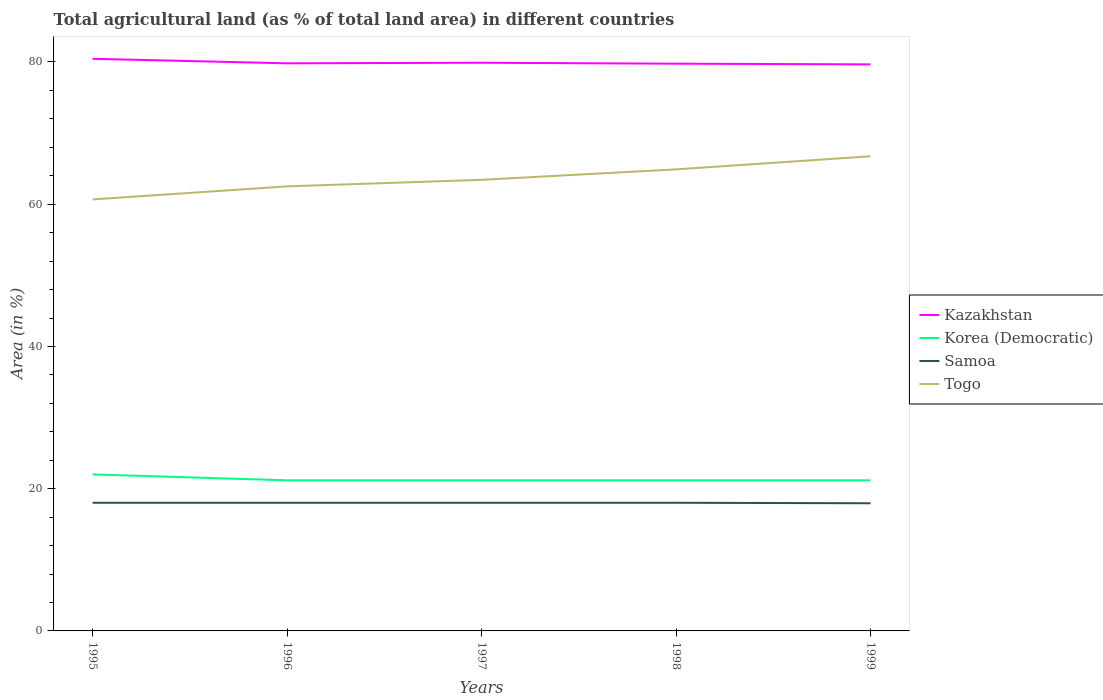Does the line corresponding to Korea (Democratic) intersect with the line corresponding to Togo?
Provide a short and direct response. No. Across all years, what is the maximum percentage of agricultural land in Samoa?
Your answer should be very brief. 17.95. In which year was the percentage of agricultural land in Samoa maximum?
Keep it short and to the point. 1999. What is the total percentage of agricultural land in Togo in the graph?
Keep it short and to the point. -3.31. What is the difference between the highest and the second highest percentage of agricultural land in Samoa?
Make the answer very short. 0.07. What is the difference between the highest and the lowest percentage of agricultural land in Korea (Democratic)?
Offer a very short reply. 1. How many years are there in the graph?
Provide a short and direct response. 5. What is the difference between two consecutive major ticks on the Y-axis?
Ensure brevity in your answer.  20. Does the graph contain any zero values?
Make the answer very short. No. Does the graph contain grids?
Ensure brevity in your answer.  No. Where does the legend appear in the graph?
Your response must be concise. Center right. How many legend labels are there?
Ensure brevity in your answer.  4. What is the title of the graph?
Offer a terse response. Total agricultural land (as % of total land area) in different countries. What is the label or title of the Y-axis?
Give a very brief answer. Area (in %). What is the Area (in %) in Kazakhstan in 1995?
Provide a succinct answer. 80.45. What is the Area (in %) in Korea (Democratic) in 1995?
Offer a very short reply. 22.01. What is the Area (in %) of Samoa in 1995?
Offer a very short reply. 18.02. What is the Area (in %) in Togo in 1995?
Make the answer very short. 60.67. What is the Area (in %) in Kazakhstan in 1996?
Your answer should be very brief. 79.81. What is the Area (in %) of Korea (Democratic) in 1996?
Offer a terse response. 21.18. What is the Area (in %) of Samoa in 1996?
Offer a terse response. 18.02. What is the Area (in %) of Togo in 1996?
Make the answer very short. 62.51. What is the Area (in %) of Kazakhstan in 1997?
Provide a short and direct response. 79.89. What is the Area (in %) in Korea (Democratic) in 1997?
Keep it short and to the point. 21.18. What is the Area (in %) of Samoa in 1997?
Offer a terse response. 18.02. What is the Area (in %) in Togo in 1997?
Provide a succinct answer. 63.43. What is the Area (in %) in Kazakhstan in 1998?
Ensure brevity in your answer.  79.76. What is the Area (in %) of Korea (Democratic) in 1998?
Keep it short and to the point. 21.18. What is the Area (in %) of Samoa in 1998?
Provide a succinct answer. 18.02. What is the Area (in %) of Togo in 1998?
Offer a very short reply. 64.9. What is the Area (in %) of Kazakhstan in 1999?
Ensure brevity in your answer.  79.67. What is the Area (in %) of Korea (Democratic) in 1999?
Offer a very short reply. 21.18. What is the Area (in %) in Samoa in 1999?
Give a very brief answer. 17.95. What is the Area (in %) in Togo in 1999?
Give a very brief answer. 66.74. Across all years, what is the maximum Area (in %) in Kazakhstan?
Keep it short and to the point. 80.45. Across all years, what is the maximum Area (in %) of Korea (Democratic)?
Your answer should be compact. 22.01. Across all years, what is the maximum Area (in %) in Samoa?
Give a very brief answer. 18.02. Across all years, what is the maximum Area (in %) in Togo?
Offer a terse response. 66.74. Across all years, what is the minimum Area (in %) of Kazakhstan?
Offer a very short reply. 79.67. Across all years, what is the minimum Area (in %) of Korea (Democratic)?
Provide a succinct answer. 21.18. Across all years, what is the minimum Area (in %) in Samoa?
Ensure brevity in your answer.  17.95. Across all years, what is the minimum Area (in %) in Togo?
Offer a terse response. 60.67. What is the total Area (in %) in Kazakhstan in the graph?
Provide a short and direct response. 399.58. What is the total Area (in %) in Korea (Democratic) in the graph?
Ensure brevity in your answer.  106.72. What is the total Area (in %) of Samoa in the graph?
Offer a terse response. 90.04. What is the total Area (in %) in Togo in the graph?
Your answer should be compact. 318.26. What is the difference between the Area (in %) in Kazakhstan in 1995 and that in 1996?
Your answer should be compact. 0.63. What is the difference between the Area (in %) in Korea (Democratic) in 1995 and that in 1996?
Offer a terse response. 0.83. What is the difference between the Area (in %) in Samoa in 1995 and that in 1996?
Keep it short and to the point. 0. What is the difference between the Area (in %) of Togo in 1995 and that in 1996?
Offer a very short reply. -1.84. What is the difference between the Area (in %) in Kazakhstan in 1995 and that in 1997?
Ensure brevity in your answer.  0.55. What is the difference between the Area (in %) in Korea (Democratic) in 1995 and that in 1997?
Give a very brief answer. 0.83. What is the difference between the Area (in %) of Samoa in 1995 and that in 1997?
Your response must be concise. 0. What is the difference between the Area (in %) in Togo in 1995 and that in 1997?
Make the answer very short. -2.76. What is the difference between the Area (in %) of Kazakhstan in 1995 and that in 1998?
Your response must be concise. 0.69. What is the difference between the Area (in %) in Korea (Democratic) in 1995 and that in 1998?
Your answer should be very brief. 0.83. What is the difference between the Area (in %) in Togo in 1995 and that in 1998?
Provide a short and direct response. -4.23. What is the difference between the Area (in %) of Kazakhstan in 1995 and that in 1999?
Offer a terse response. 0.78. What is the difference between the Area (in %) in Korea (Democratic) in 1995 and that in 1999?
Give a very brief answer. 0.83. What is the difference between the Area (in %) of Samoa in 1995 and that in 1999?
Your response must be concise. 0.07. What is the difference between the Area (in %) of Togo in 1995 and that in 1999?
Give a very brief answer. -6.07. What is the difference between the Area (in %) of Kazakhstan in 1996 and that in 1997?
Make the answer very short. -0.08. What is the difference between the Area (in %) of Korea (Democratic) in 1996 and that in 1997?
Offer a very short reply. 0. What is the difference between the Area (in %) of Samoa in 1996 and that in 1997?
Offer a terse response. 0. What is the difference between the Area (in %) in Togo in 1996 and that in 1997?
Provide a succinct answer. -0.92. What is the difference between the Area (in %) in Kazakhstan in 1996 and that in 1998?
Offer a very short reply. 0.05. What is the difference between the Area (in %) in Korea (Democratic) in 1996 and that in 1998?
Your answer should be compact. 0. What is the difference between the Area (in %) in Samoa in 1996 and that in 1998?
Your answer should be very brief. 0. What is the difference between the Area (in %) of Togo in 1996 and that in 1998?
Make the answer very short. -2.39. What is the difference between the Area (in %) in Kazakhstan in 1996 and that in 1999?
Keep it short and to the point. 0.15. What is the difference between the Area (in %) of Samoa in 1996 and that in 1999?
Provide a short and direct response. 0.07. What is the difference between the Area (in %) in Togo in 1996 and that in 1999?
Ensure brevity in your answer.  -4.23. What is the difference between the Area (in %) of Kazakhstan in 1997 and that in 1998?
Your answer should be compact. 0.13. What is the difference between the Area (in %) in Korea (Democratic) in 1997 and that in 1998?
Your answer should be very brief. 0. What is the difference between the Area (in %) in Togo in 1997 and that in 1998?
Provide a succinct answer. -1.47. What is the difference between the Area (in %) of Kazakhstan in 1997 and that in 1999?
Ensure brevity in your answer.  0.23. What is the difference between the Area (in %) of Samoa in 1997 and that in 1999?
Your answer should be very brief. 0.07. What is the difference between the Area (in %) in Togo in 1997 and that in 1999?
Provide a succinct answer. -3.31. What is the difference between the Area (in %) in Kazakhstan in 1998 and that in 1999?
Your response must be concise. 0.09. What is the difference between the Area (in %) in Samoa in 1998 and that in 1999?
Make the answer very short. 0.07. What is the difference between the Area (in %) in Togo in 1998 and that in 1999?
Your answer should be very brief. -1.84. What is the difference between the Area (in %) in Kazakhstan in 1995 and the Area (in %) in Korea (Democratic) in 1996?
Ensure brevity in your answer.  59.27. What is the difference between the Area (in %) of Kazakhstan in 1995 and the Area (in %) of Samoa in 1996?
Offer a terse response. 62.43. What is the difference between the Area (in %) in Kazakhstan in 1995 and the Area (in %) in Togo in 1996?
Provide a short and direct response. 17.94. What is the difference between the Area (in %) of Korea (Democratic) in 1995 and the Area (in %) of Samoa in 1996?
Your answer should be very brief. 3.99. What is the difference between the Area (in %) in Korea (Democratic) in 1995 and the Area (in %) in Togo in 1996?
Give a very brief answer. -40.5. What is the difference between the Area (in %) in Samoa in 1995 and the Area (in %) in Togo in 1996?
Keep it short and to the point. -44.49. What is the difference between the Area (in %) of Kazakhstan in 1995 and the Area (in %) of Korea (Democratic) in 1997?
Offer a terse response. 59.27. What is the difference between the Area (in %) in Kazakhstan in 1995 and the Area (in %) in Samoa in 1997?
Ensure brevity in your answer.  62.43. What is the difference between the Area (in %) in Kazakhstan in 1995 and the Area (in %) in Togo in 1997?
Give a very brief answer. 17.02. What is the difference between the Area (in %) of Korea (Democratic) in 1995 and the Area (in %) of Samoa in 1997?
Your response must be concise. 3.99. What is the difference between the Area (in %) in Korea (Democratic) in 1995 and the Area (in %) in Togo in 1997?
Keep it short and to the point. -41.42. What is the difference between the Area (in %) of Samoa in 1995 and the Area (in %) of Togo in 1997?
Ensure brevity in your answer.  -45.41. What is the difference between the Area (in %) of Kazakhstan in 1995 and the Area (in %) of Korea (Democratic) in 1998?
Ensure brevity in your answer.  59.27. What is the difference between the Area (in %) of Kazakhstan in 1995 and the Area (in %) of Samoa in 1998?
Offer a terse response. 62.43. What is the difference between the Area (in %) in Kazakhstan in 1995 and the Area (in %) in Togo in 1998?
Keep it short and to the point. 15.55. What is the difference between the Area (in %) of Korea (Democratic) in 1995 and the Area (in %) of Samoa in 1998?
Your answer should be very brief. 3.99. What is the difference between the Area (in %) in Korea (Democratic) in 1995 and the Area (in %) in Togo in 1998?
Keep it short and to the point. -42.89. What is the difference between the Area (in %) in Samoa in 1995 and the Area (in %) in Togo in 1998?
Your answer should be compact. -46.88. What is the difference between the Area (in %) of Kazakhstan in 1995 and the Area (in %) of Korea (Democratic) in 1999?
Keep it short and to the point. 59.27. What is the difference between the Area (in %) of Kazakhstan in 1995 and the Area (in %) of Samoa in 1999?
Offer a terse response. 62.5. What is the difference between the Area (in %) of Kazakhstan in 1995 and the Area (in %) of Togo in 1999?
Provide a short and direct response. 13.71. What is the difference between the Area (in %) in Korea (Democratic) in 1995 and the Area (in %) in Samoa in 1999?
Keep it short and to the point. 4.06. What is the difference between the Area (in %) of Korea (Democratic) in 1995 and the Area (in %) of Togo in 1999?
Make the answer very short. -44.73. What is the difference between the Area (in %) of Samoa in 1995 and the Area (in %) of Togo in 1999?
Offer a terse response. -48.72. What is the difference between the Area (in %) of Kazakhstan in 1996 and the Area (in %) of Korea (Democratic) in 1997?
Offer a very short reply. 58.64. What is the difference between the Area (in %) of Kazakhstan in 1996 and the Area (in %) of Samoa in 1997?
Offer a very short reply. 61.79. What is the difference between the Area (in %) in Kazakhstan in 1996 and the Area (in %) in Togo in 1997?
Offer a terse response. 16.38. What is the difference between the Area (in %) in Korea (Democratic) in 1996 and the Area (in %) in Samoa in 1997?
Your response must be concise. 3.16. What is the difference between the Area (in %) of Korea (Democratic) in 1996 and the Area (in %) of Togo in 1997?
Provide a short and direct response. -42.25. What is the difference between the Area (in %) in Samoa in 1996 and the Area (in %) in Togo in 1997?
Provide a short and direct response. -45.41. What is the difference between the Area (in %) of Kazakhstan in 1996 and the Area (in %) of Korea (Democratic) in 1998?
Make the answer very short. 58.64. What is the difference between the Area (in %) in Kazakhstan in 1996 and the Area (in %) in Samoa in 1998?
Make the answer very short. 61.79. What is the difference between the Area (in %) of Kazakhstan in 1996 and the Area (in %) of Togo in 1998?
Provide a succinct answer. 14.91. What is the difference between the Area (in %) in Korea (Democratic) in 1996 and the Area (in %) in Samoa in 1998?
Provide a short and direct response. 3.16. What is the difference between the Area (in %) in Korea (Democratic) in 1996 and the Area (in %) in Togo in 1998?
Your answer should be compact. -43.72. What is the difference between the Area (in %) in Samoa in 1996 and the Area (in %) in Togo in 1998?
Provide a succinct answer. -46.88. What is the difference between the Area (in %) of Kazakhstan in 1996 and the Area (in %) of Korea (Democratic) in 1999?
Your answer should be very brief. 58.64. What is the difference between the Area (in %) in Kazakhstan in 1996 and the Area (in %) in Samoa in 1999?
Make the answer very short. 61.86. What is the difference between the Area (in %) of Kazakhstan in 1996 and the Area (in %) of Togo in 1999?
Your answer should be compact. 13.07. What is the difference between the Area (in %) of Korea (Democratic) in 1996 and the Area (in %) of Samoa in 1999?
Give a very brief answer. 3.23. What is the difference between the Area (in %) of Korea (Democratic) in 1996 and the Area (in %) of Togo in 1999?
Offer a terse response. -45.56. What is the difference between the Area (in %) in Samoa in 1996 and the Area (in %) in Togo in 1999?
Give a very brief answer. -48.72. What is the difference between the Area (in %) in Kazakhstan in 1997 and the Area (in %) in Korea (Democratic) in 1998?
Keep it short and to the point. 58.72. What is the difference between the Area (in %) of Kazakhstan in 1997 and the Area (in %) of Samoa in 1998?
Your answer should be compact. 61.87. What is the difference between the Area (in %) of Kazakhstan in 1997 and the Area (in %) of Togo in 1998?
Make the answer very short. 14.99. What is the difference between the Area (in %) in Korea (Democratic) in 1997 and the Area (in %) in Samoa in 1998?
Keep it short and to the point. 3.16. What is the difference between the Area (in %) of Korea (Democratic) in 1997 and the Area (in %) of Togo in 1998?
Offer a very short reply. -43.72. What is the difference between the Area (in %) in Samoa in 1997 and the Area (in %) in Togo in 1998?
Provide a short and direct response. -46.88. What is the difference between the Area (in %) of Kazakhstan in 1997 and the Area (in %) of Korea (Democratic) in 1999?
Your response must be concise. 58.72. What is the difference between the Area (in %) in Kazakhstan in 1997 and the Area (in %) in Samoa in 1999?
Ensure brevity in your answer.  61.94. What is the difference between the Area (in %) of Kazakhstan in 1997 and the Area (in %) of Togo in 1999?
Ensure brevity in your answer.  13.15. What is the difference between the Area (in %) of Korea (Democratic) in 1997 and the Area (in %) of Samoa in 1999?
Your answer should be compact. 3.23. What is the difference between the Area (in %) of Korea (Democratic) in 1997 and the Area (in %) of Togo in 1999?
Make the answer very short. -45.56. What is the difference between the Area (in %) in Samoa in 1997 and the Area (in %) in Togo in 1999?
Offer a terse response. -48.72. What is the difference between the Area (in %) in Kazakhstan in 1998 and the Area (in %) in Korea (Democratic) in 1999?
Offer a very short reply. 58.58. What is the difference between the Area (in %) in Kazakhstan in 1998 and the Area (in %) in Samoa in 1999?
Offer a terse response. 61.81. What is the difference between the Area (in %) in Kazakhstan in 1998 and the Area (in %) in Togo in 1999?
Your answer should be very brief. 13.02. What is the difference between the Area (in %) of Korea (Democratic) in 1998 and the Area (in %) of Samoa in 1999?
Make the answer very short. 3.23. What is the difference between the Area (in %) in Korea (Democratic) in 1998 and the Area (in %) in Togo in 1999?
Your answer should be compact. -45.56. What is the difference between the Area (in %) in Samoa in 1998 and the Area (in %) in Togo in 1999?
Ensure brevity in your answer.  -48.72. What is the average Area (in %) in Kazakhstan per year?
Make the answer very short. 79.92. What is the average Area (in %) of Korea (Democratic) per year?
Your answer should be compact. 21.34. What is the average Area (in %) in Samoa per year?
Your answer should be compact. 18.01. What is the average Area (in %) in Togo per year?
Your response must be concise. 63.65. In the year 1995, what is the difference between the Area (in %) of Kazakhstan and Area (in %) of Korea (Democratic)?
Give a very brief answer. 58.44. In the year 1995, what is the difference between the Area (in %) of Kazakhstan and Area (in %) of Samoa?
Provide a short and direct response. 62.43. In the year 1995, what is the difference between the Area (in %) of Kazakhstan and Area (in %) of Togo?
Your answer should be compact. 19.78. In the year 1995, what is the difference between the Area (in %) of Korea (Democratic) and Area (in %) of Samoa?
Your answer should be very brief. 3.99. In the year 1995, what is the difference between the Area (in %) of Korea (Democratic) and Area (in %) of Togo?
Give a very brief answer. -38.66. In the year 1995, what is the difference between the Area (in %) in Samoa and Area (in %) in Togo?
Your response must be concise. -42.65. In the year 1996, what is the difference between the Area (in %) in Kazakhstan and Area (in %) in Korea (Democratic)?
Keep it short and to the point. 58.64. In the year 1996, what is the difference between the Area (in %) in Kazakhstan and Area (in %) in Samoa?
Ensure brevity in your answer.  61.79. In the year 1996, what is the difference between the Area (in %) of Kazakhstan and Area (in %) of Togo?
Ensure brevity in your answer.  17.3. In the year 1996, what is the difference between the Area (in %) in Korea (Democratic) and Area (in %) in Samoa?
Keep it short and to the point. 3.16. In the year 1996, what is the difference between the Area (in %) in Korea (Democratic) and Area (in %) in Togo?
Keep it short and to the point. -41.33. In the year 1996, what is the difference between the Area (in %) of Samoa and Area (in %) of Togo?
Keep it short and to the point. -44.49. In the year 1997, what is the difference between the Area (in %) of Kazakhstan and Area (in %) of Korea (Democratic)?
Provide a short and direct response. 58.72. In the year 1997, what is the difference between the Area (in %) of Kazakhstan and Area (in %) of Samoa?
Give a very brief answer. 61.87. In the year 1997, what is the difference between the Area (in %) of Kazakhstan and Area (in %) of Togo?
Ensure brevity in your answer.  16.46. In the year 1997, what is the difference between the Area (in %) of Korea (Democratic) and Area (in %) of Samoa?
Offer a terse response. 3.16. In the year 1997, what is the difference between the Area (in %) in Korea (Democratic) and Area (in %) in Togo?
Your answer should be very brief. -42.25. In the year 1997, what is the difference between the Area (in %) of Samoa and Area (in %) of Togo?
Ensure brevity in your answer.  -45.41. In the year 1998, what is the difference between the Area (in %) of Kazakhstan and Area (in %) of Korea (Democratic)?
Give a very brief answer. 58.58. In the year 1998, what is the difference between the Area (in %) of Kazakhstan and Area (in %) of Samoa?
Offer a very short reply. 61.74. In the year 1998, what is the difference between the Area (in %) in Kazakhstan and Area (in %) in Togo?
Ensure brevity in your answer.  14.86. In the year 1998, what is the difference between the Area (in %) of Korea (Democratic) and Area (in %) of Samoa?
Offer a terse response. 3.16. In the year 1998, what is the difference between the Area (in %) of Korea (Democratic) and Area (in %) of Togo?
Keep it short and to the point. -43.72. In the year 1998, what is the difference between the Area (in %) in Samoa and Area (in %) in Togo?
Offer a very short reply. -46.88. In the year 1999, what is the difference between the Area (in %) of Kazakhstan and Area (in %) of Korea (Democratic)?
Provide a succinct answer. 58.49. In the year 1999, what is the difference between the Area (in %) in Kazakhstan and Area (in %) in Samoa?
Make the answer very short. 61.72. In the year 1999, what is the difference between the Area (in %) in Kazakhstan and Area (in %) in Togo?
Your answer should be very brief. 12.93. In the year 1999, what is the difference between the Area (in %) in Korea (Democratic) and Area (in %) in Samoa?
Keep it short and to the point. 3.23. In the year 1999, what is the difference between the Area (in %) of Korea (Democratic) and Area (in %) of Togo?
Provide a succinct answer. -45.56. In the year 1999, what is the difference between the Area (in %) in Samoa and Area (in %) in Togo?
Ensure brevity in your answer.  -48.79. What is the ratio of the Area (in %) in Kazakhstan in 1995 to that in 1996?
Ensure brevity in your answer.  1.01. What is the ratio of the Area (in %) in Korea (Democratic) in 1995 to that in 1996?
Offer a terse response. 1.04. What is the ratio of the Area (in %) of Togo in 1995 to that in 1996?
Keep it short and to the point. 0.97. What is the ratio of the Area (in %) of Korea (Democratic) in 1995 to that in 1997?
Keep it short and to the point. 1.04. What is the ratio of the Area (in %) in Togo in 1995 to that in 1997?
Provide a succinct answer. 0.96. What is the ratio of the Area (in %) in Kazakhstan in 1995 to that in 1998?
Offer a terse response. 1.01. What is the ratio of the Area (in %) of Korea (Democratic) in 1995 to that in 1998?
Ensure brevity in your answer.  1.04. What is the ratio of the Area (in %) of Togo in 1995 to that in 1998?
Give a very brief answer. 0.93. What is the ratio of the Area (in %) of Kazakhstan in 1995 to that in 1999?
Keep it short and to the point. 1.01. What is the ratio of the Area (in %) of Korea (Democratic) in 1995 to that in 1999?
Keep it short and to the point. 1.04. What is the ratio of the Area (in %) of Togo in 1995 to that in 1999?
Provide a short and direct response. 0.91. What is the ratio of the Area (in %) of Kazakhstan in 1996 to that in 1997?
Give a very brief answer. 1. What is the ratio of the Area (in %) in Togo in 1996 to that in 1997?
Your response must be concise. 0.99. What is the ratio of the Area (in %) in Kazakhstan in 1996 to that in 1998?
Give a very brief answer. 1. What is the ratio of the Area (in %) in Samoa in 1996 to that in 1998?
Your response must be concise. 1. What is the ratio of the Area (in %) in Togo in 1996 to that in 1998?
Keep it short and to the point. 0.96. What is the ratio of the Area (in %) in Togo in 1996 to that in 1999?
Your response must be concise. 0.94. What is the ratio of the Area (in %) of Korea (Democratic) in 1997 to that in 1998?
Your answer should be compact. 1. What is the ratio of the Area (in %) of Togo in 1997 to that in 1998?
Keep it short and to the point. 0.98. What is the ratio of the Area (in %) of Kazakhstan in 1997 to that in 1999?
Offer a very short reply. 1. What is the ratio of the Area (in %) in Samoa in 1997 to that in 1999?
Ensure brevity in your answer.  1. What is the ratio of the Area (in %) of Togo in 1997 to that in 1999?
Your response must be concise. 0.95. What is the ratio of the Area (in %) in Samoa in 1998 to that in 1999?
Keep it short and to the point. 1. What is the ratio of the Area (in %) of Togo in 1998 to that in 1999?
Your answer should be very brief. 0.97. What is the difference between the highest and the second highest Area (in %) in Kazakhstan?
Your response must be concise. 0.55. What is the difference between the highest and the second highest Area (in %) of Korea (Democratic)?
Your answer should be compact. 0.83. What is the difference between the highest and the second highest Area (in %) in Samoa?
Your response must be concise. 0. What is the difference between the highest and the second highest Area (in %) of Togo?
Provide a succinct answer. 1.84. What is the difference between the highest and the lowest Area (in %) in Kazakhstan?
Ensure brevity in your answer.  0.78. What is the difference between the highest and the lowest Area (in %) of Korea (Democratic)?
Your response must be concise. 0.83. What is the difference between the highest and the lowest Area (in %) in Samoa?
Your answer should be compact. 0.07. What is the difference between the highest and the lowest Area (in %) in Togo?
Your answer should be very brief. 6.07. 